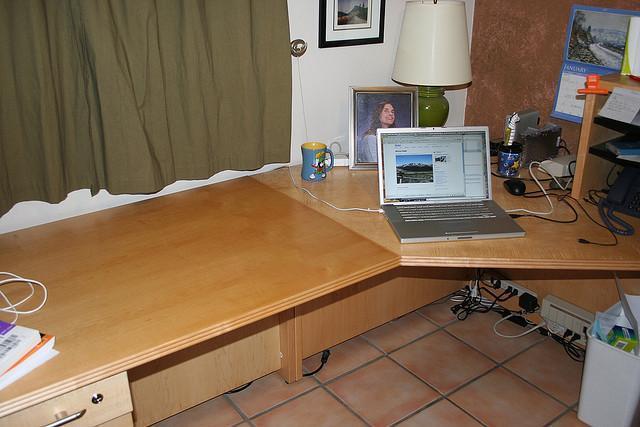How many laptops are there?
Give a very brief answer. 1. 